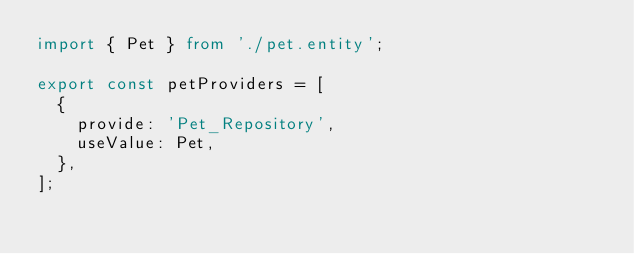Convert code to text. <code><loc_0><loc_0><loc_500><loc_500><_TypeScript_>import { Pet } from './pet.entity';

export const petProviders = [
  {
    provide: 'Pet_Repository',
    useValue: Pet,
  },
];
</code> 